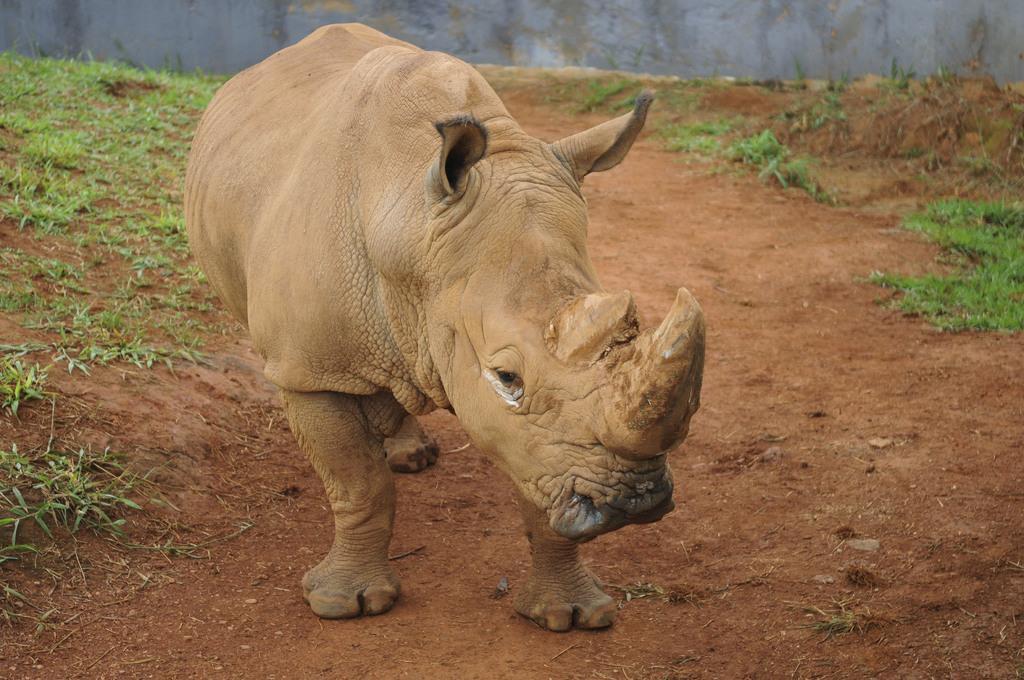In one or two sentences, can you explain what this image depicts? In this image, we can see a rhinoceros on the ground. On the left side and right side of the image, we can see grass. At the top of the image, there is a wall. 